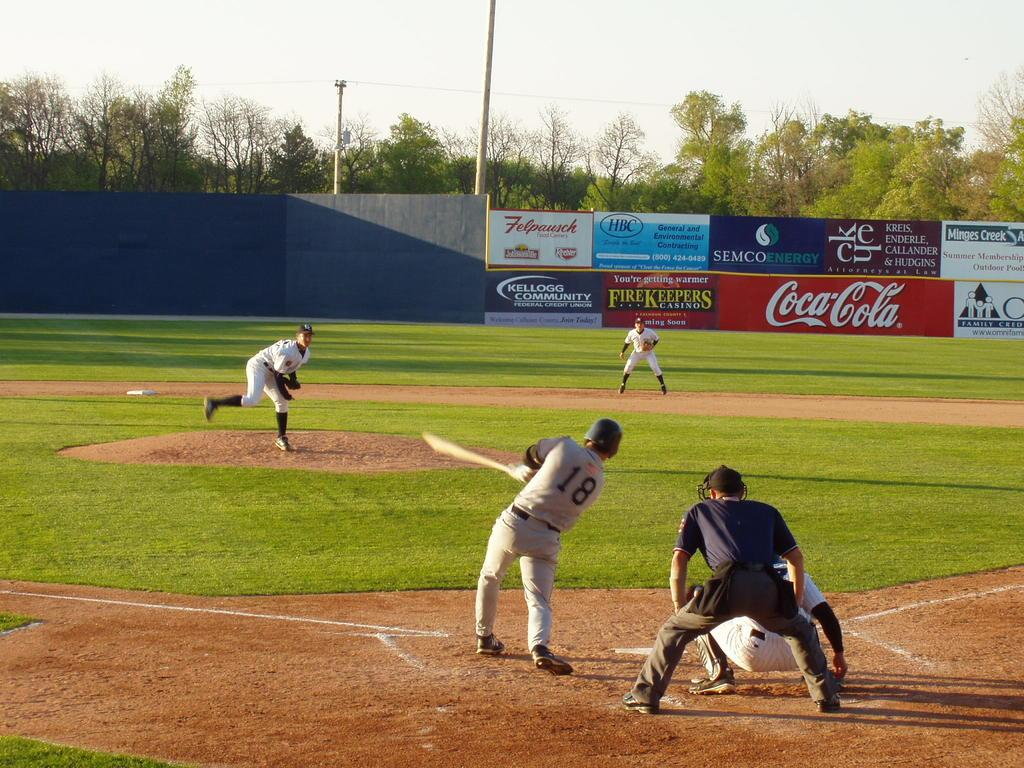<image>
Describe the image concisely. A baseball player wearing the number 18 hits a baseball. 